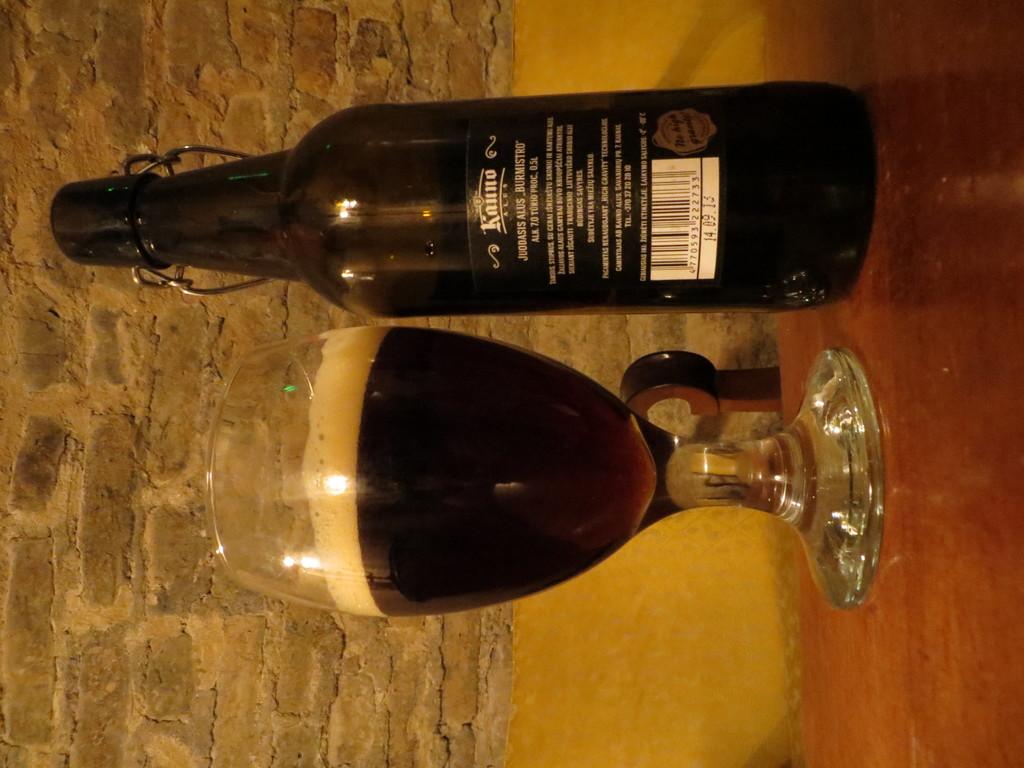Wht is the date at the bottom of the label?
Keep it short and to the point. 14.09.13. 